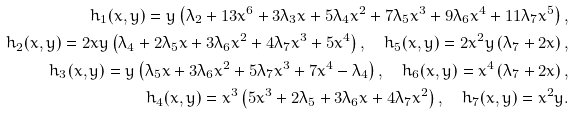Convert formula to latex. <formula><loc_0><loc_0><loc_500><loc_500>h _ { 1 } ( x , y ) = y \left ( \lambda _ { 2 } + 1 3 x ^ { 6 } + 3 \lambda _ { 3 } x + 5 \lambda _ { 4 } x ^ { 2 } + 7 \lambda _ { 5 } x ^ { 3 } + 9 \lambda _ { 6 } x ^ { 4 } + 1 1 \lambda _ { 7 } x ^ { 5 } \right ) , \\ h _ { 2 } ( x , y ) = 2 x y \left ( \lambda _ { 4 } + 2 \lambda _ { 5 } x + 3 \lambda _ { 6 } x ^ { 2 } + 4 \lambda _ { 7 } x ^ { 3 } + 5 x ^ { 4 } \right ) , \quad h _ { 5 } ( x , y ) = 2 x ^ { 2 } y \left ( \lambda _ { 7 } + 2 x \right ) , \\ h _ { 3 } ( x , y ) = y \left ( \lambda _ { 5 } x + 3 \lambda _ { 6 } x ^ { 2 } + 5 \lambda _ { 7 } x ^ { 3 } + 7 x ^ { 4 } - \lambda _ { 4 } \right ) , \quad h _ { 6 } ( x , y ) = x ^ { 4 } \left ( \lambda _ { 7 } + 2 x \right ) , \\ h _ { 4 } ( x , y ) = x ^ { 3 } \left ( 5 x ^ { 3 } + 2 \lambda _ { 5 } + 3 \lambda _ { 6 } x + 4 \lambda _ { 7 } x ^ { 2 } \right ) , \quad h _ { 7 } ( x , y ) = x ^ { 2 } y .</formula> 